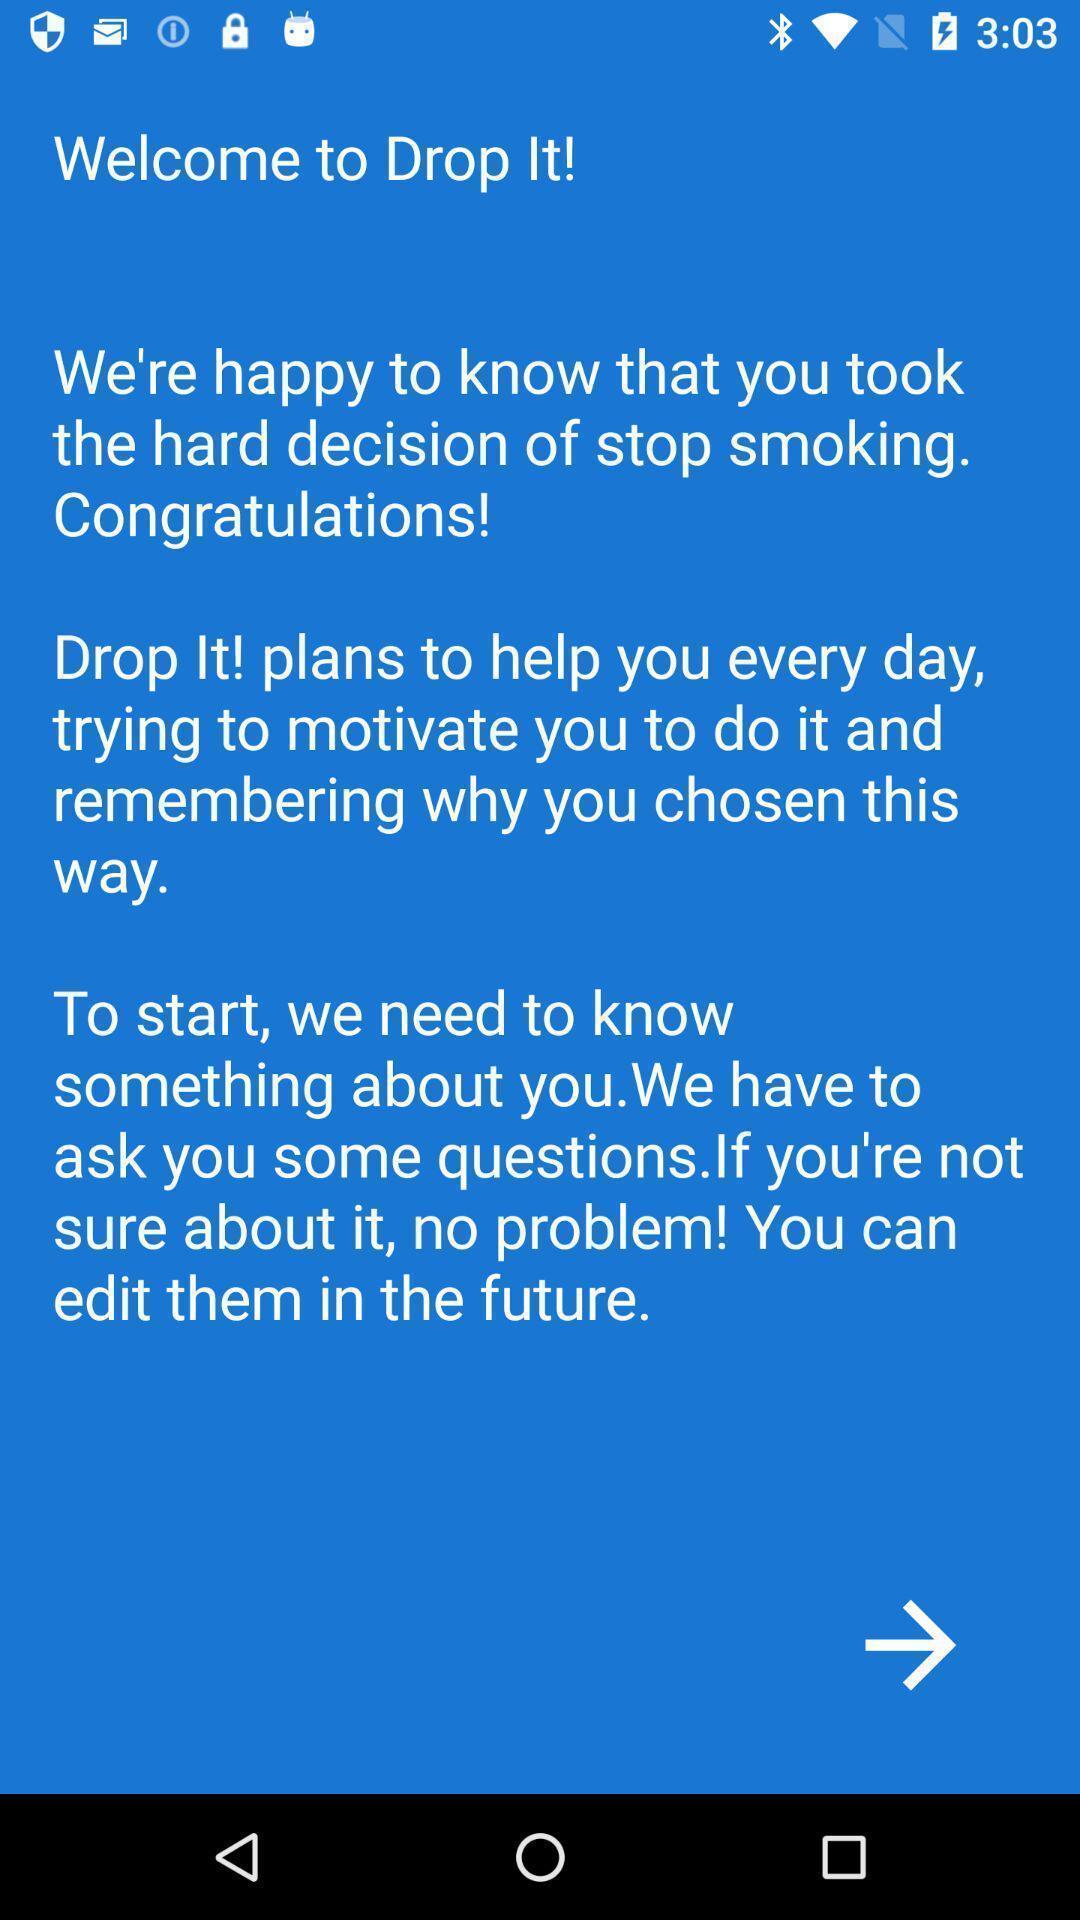Give me a summary of this screen capture. Welcome page. 